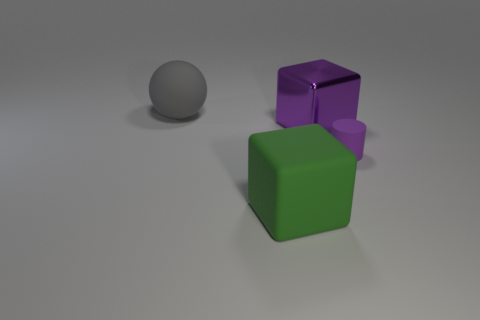How many things are either metal blocks or green metallic cylinders?
Ensure brevity in your answer.  1. The sphere that is the same size as the shiny block is what color?
Your response must be concise. Gray. What number of things are things in front of the cylinder or tiny cyan blocks?
Ensure brevity in your answer.  1. What number of other things are there of the same size as the gray object?
Make the answer very short. 2. What is the size of the purple thing that is behind the small purple rubber cylinder?
Offer a terse response. Large. What is the shape of the tiny purple thing that is the same material as the green block?
Give a very brief answer. Cylinder. Is there anything else of the same color as the large rubber ball?
Offer a terse response. No. There is a large rubber object that is in front of the rubber object behind the tiny object; what color is it?
Give a very brief answer. Green. What number of large objects are rubber spheres or purple blocks?
Provide a short and direct response. 2. There is another large green object that is the same shape as the large metallic object; what material is it?
Make the answer very short. Rubber. 